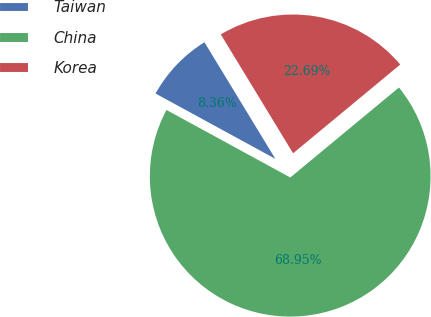Convert chart. <chart><loc_0><loc_0><loc_500><loc_500><pie_chart><fcel>Taiwan<fcel>China<fcel>Korea<nl><fcel>8.36%<fcel>68.96%<fcel>22.69%<nl></chart> 